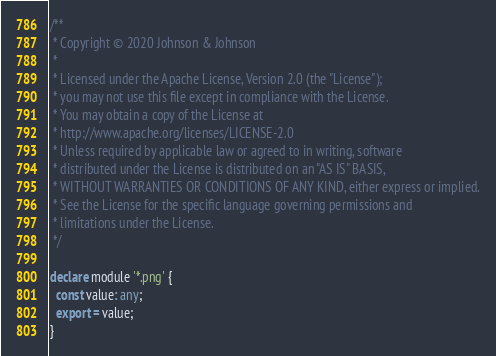<code> <loc_0><loc_0><loc_500><loc_500><_TypeScript_>/**
 * Copyright © 2020 Johnson & Johnson
 *
 * Licensed under the Apache License, Version 2.0 (the "License");
 * you may not use this file except in compliance with the License.
 * You may obtain a copy of the License at
 * http://www.apache.org/licenses/LICENSE-2.0
 * Unless required by applicable law or agreed to in writing, software
 * distributed under the License is distributed on an "AS IS" BASIS,
 * WITHOUT WARRANTIES OR CONDITIONS OF ANY KIND, either express or implied.
 * See the License for the specific language governing permissions and
 * limitations under the License.
 */

declare module '*.png' {
  const value: any;
  export = value;
}
</code> 